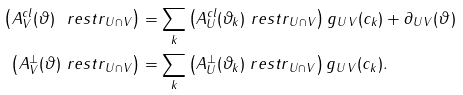<formula> <loc_0><loc_0><loc_500><loc_500>\left ( A _ { V } ^ { c l } ( \vartheta ) { \ r e s t r } _ { U \cap V } \right ) & = \sum _ { k } \left ( A _ { U } ^ { c l } ( \vartheta _ { k } ) { \ r e s t r } _ { U \cap V } \right ) g _ { U \, V } ( c _ { k } ) + \partial _ { U \, V } ( \vartheta ) \\ \left ( A _ { V } ^ { \perp } ( \vartheta ) { \ r e s t r } _ { U \cap V } \right ) & = \sum _ { k } \left ( A _ { U } ^ { \perp } ( \vartheta _ { k } ) { \ r e s t r } _ { U \cap V } \right ) g _ { U \, V } ( c _ { k } ) .</formula> 